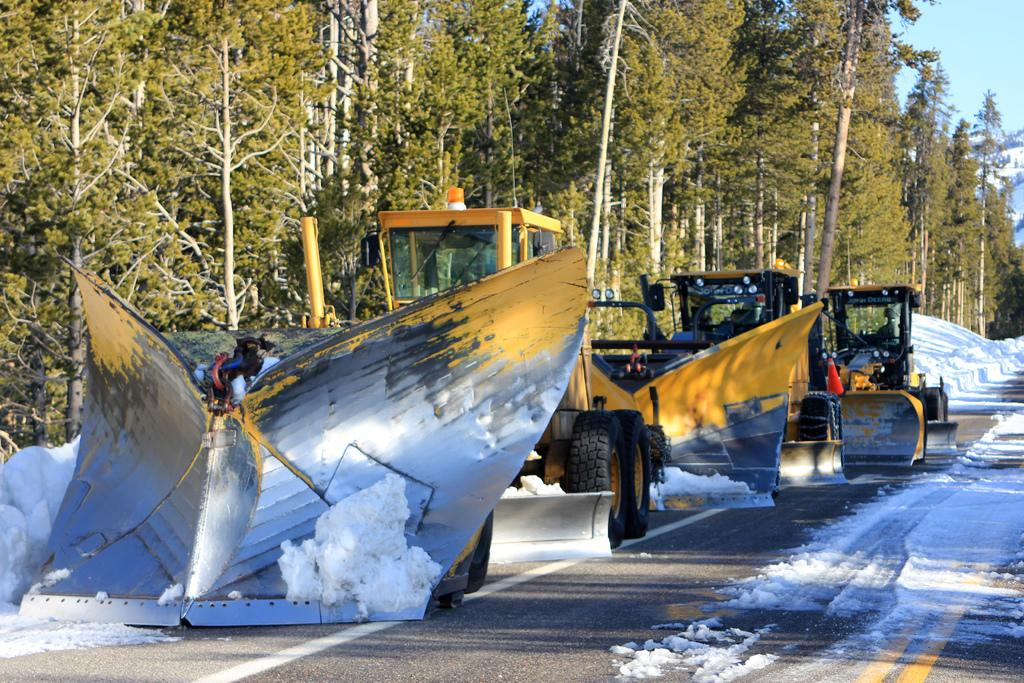What can be seen on the road in the image? There are vehicles on the road in the image. What is visible behind the vehicles? There are trees visible behind the vehicles. What is the weather like in the image? There is snow in the image, indicating a winter setting. What geographical features can be seen in the top right side of the image? There are hills visible in the top right side of the image. What is visible in the sky in the image? The sky is visible in the image. Where is the secretary sitting in the image? There is no secretary present in the image. What type of wing can be seen on the vehicles in the image? The vehicles in the image do not have wings; they are likely cars or trucks. 